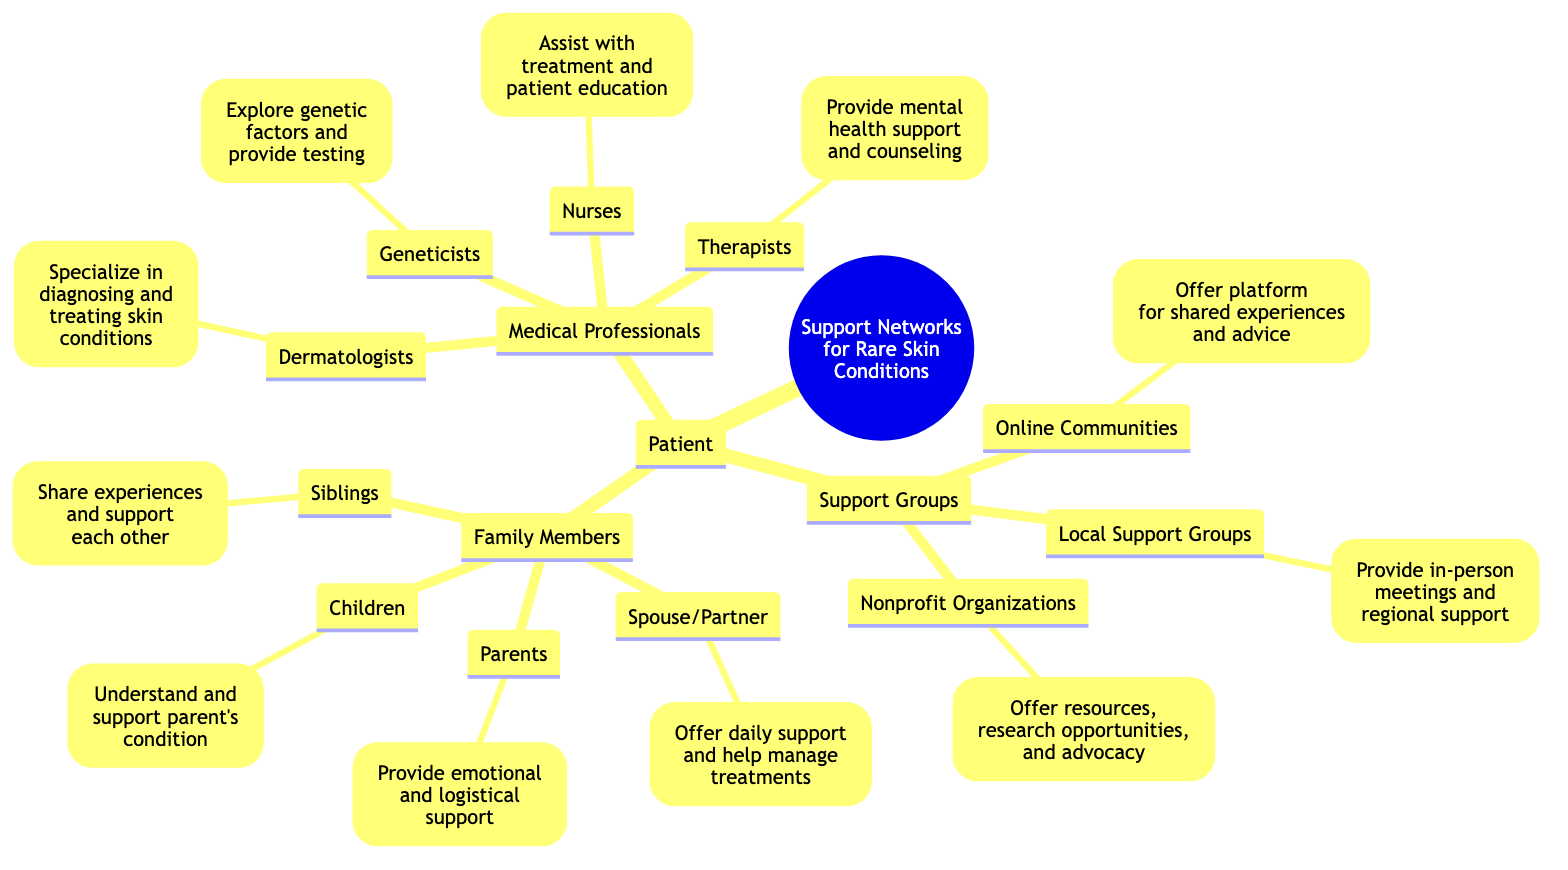What is the main focus of the diagram? The diagram's title "Support Networks for Rare Skin Conditions" indicates that the main focus is on the various support systems surrounding patients with rare skin conditions.
Answer: Support Networks for Rare Skin Conditions How many categories of support are outlined for the patient? The diagram lists three main categories under the patient: Family Members, Medical Professionals, and Support Groups. Counting each category gives a total of three.
Answer: 3 Who provides emotional and logistical support? In the "Family Members" category, "Parents" are specifically mentioned to provide emotional and logistical support to the patient.
Answer: Parents Which medical professional specializes in diagnosing and treating skin conditions? The diagram specifies "Dermatologists" as the professionals who specialize in diagnosing and treating skin conditions.
Answer: Dermatologists What is the role of therapists in this support network? According to the diagram, therapists provide mental health support and counseling, indicating their role in the broader support network for patients.
Answer: Provide mental health support and counseling How many types of support groups are listed? In the "Support Groups" section, there are three types mentioned: Online Communities, Local Support Groups, and Nonprofit Organizations. Therefore, the count of support group types is three.
Answer: 3 Which family member helps manage treatments? The diagram denotes "Spouse/Partner" as the family member who offers daily support and help manage treatments, highlighting their caregiving role.
Answer: Spouse/Partner What type of support do nonprofit organizations provide? The diagram states that nonprofit organizations offer resources, research opportunities, and advocacy, indicating a broad scope of support within this category.
Answer: Offer resources, research opportunities, and advocacy Which support group offers a platform for shared experiences? According to the diagram, "Online Communities" are designated as the support group that offers a platform for shared experiences and advice.
Answer: Online Communities 